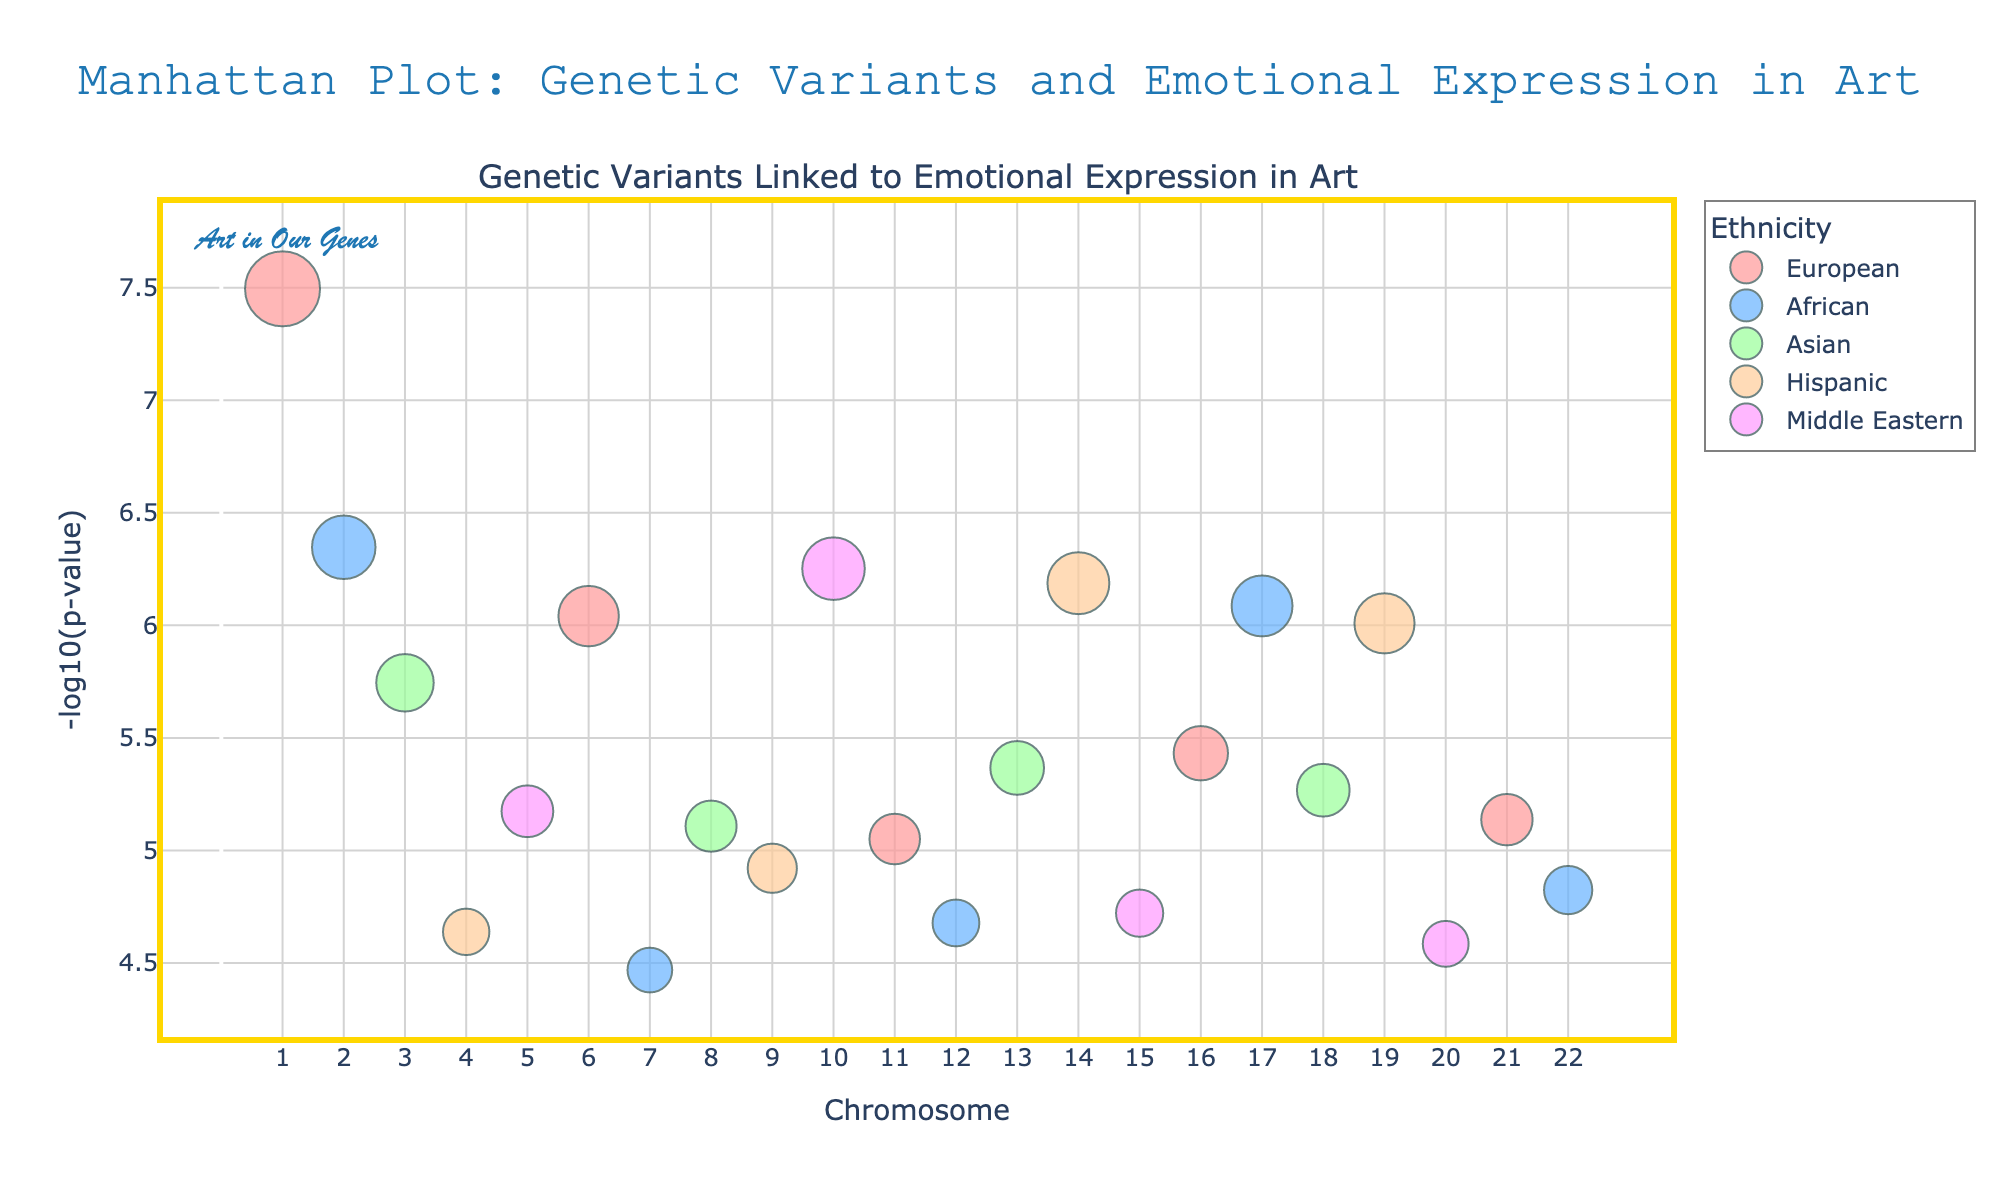What's the title of the figure? The title is located at the top center of the figure, which reads "Manhattan Plot: Genetic Variants and Emotional Expression in Art".
Answer: Manhattan Plot: Genetic Variants and Emotional Expression in Art What is on the y-axis of the figure? The y-axis is labeled as "-log10(p-value)", which represents the transformed p-values of the genetic variants.
Answer: -log10(p-value) How many chromosomes are displayed on the x-axis? The x-axis shows numbers ranging from 1 to 22, indicating a total of 22 chromosomes.
Answer: 22 What ethnicity is represented by the color '#66B2FF'? The color '#66B2FF' is used to represent the African ethnicity in the color map provided in the figure's legend.
Answer: African Which gene has the lowest p-value on chromosome 1? By inspecting chromosome 1 on the x-axis and the relevant points, the gene BDNF has the lowest p-value due to its highest -log10(p) value.
Answer: BDNF How many genetic variants are associated with the European ethnicity? To answer this, count the number of points in the European category in the legend: BDNF (1), MAOA (1), OPCML (1), GRIN2A (1), and CREB1 (1). Therefore, there are 5 genetic variants associated with Europeans.
Answer: 5 Which genetic variant has the highest -log10(p) value? By looking for the highest point on the y-axis, the variant BDNF on chromosome 1 has the highest -log10(p) value.
Answer: BDNF Among Asian and Hispanic ethnicities, which has a higher -log10(p-value) variant on chromosome 9? On chromosome 9, compare the points representing Asian and Hispanic ethnicities. The Hispanic variant HTR2A has a higher -log10(p) value compared to the Asian variants.
Answer: Hispanic What is the -log10(p-value) range for the Middle Eastern ethnicity? The Middle Eastern points on the plot have -log10(p) values visualized by their height. Observing the markers for Middle Eastern variants shows a range approximately from 5.2 to 6.3.
Answer: 5.2 to 6.3 Which ethnic group has the variant with the smallest p-value, and what is that gene? The smallest p-value corresponds to the highest -log10(p) value. The highest point, representing the BDNF gene on chromosome 1, belongs to the European ethnic group.
Answer: European, BDNF 